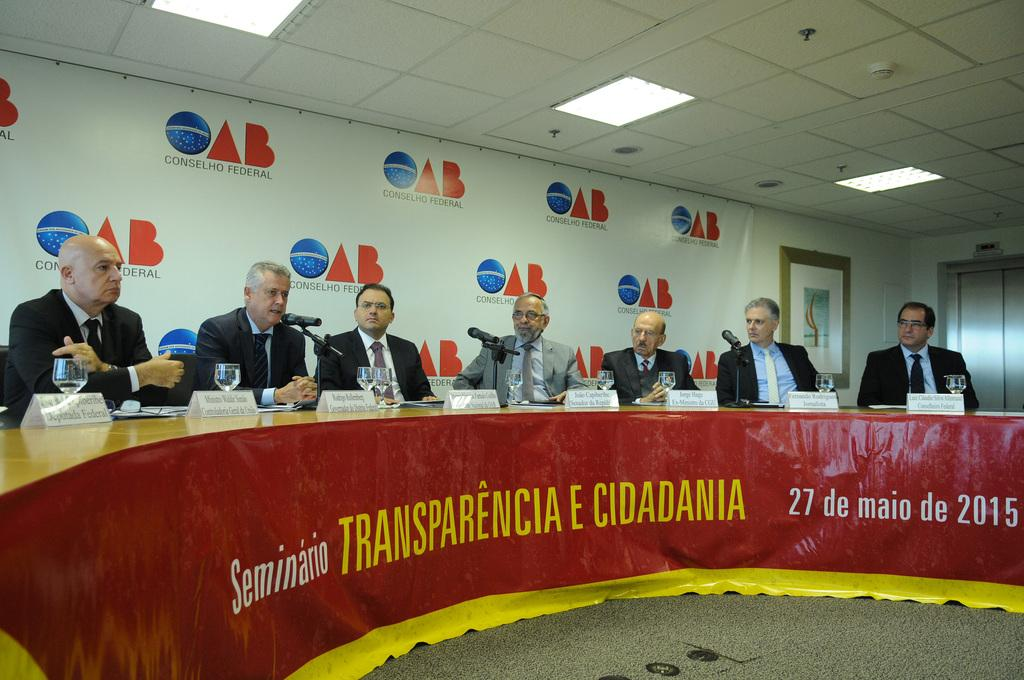What are the people in the image doing? The people in the image are sitting on chairs. What can be seen hanging on the wall in the image? There is a photo frame in the image. What is hanging above the people in the image? There is a banner in the image. What items are on the table in the image? There are glasses and microphones (mics) on the table in the image. Where is the map located in the image? There is no map present in the image. What is the doctor doing in the image? There is no doctor present in the image. 